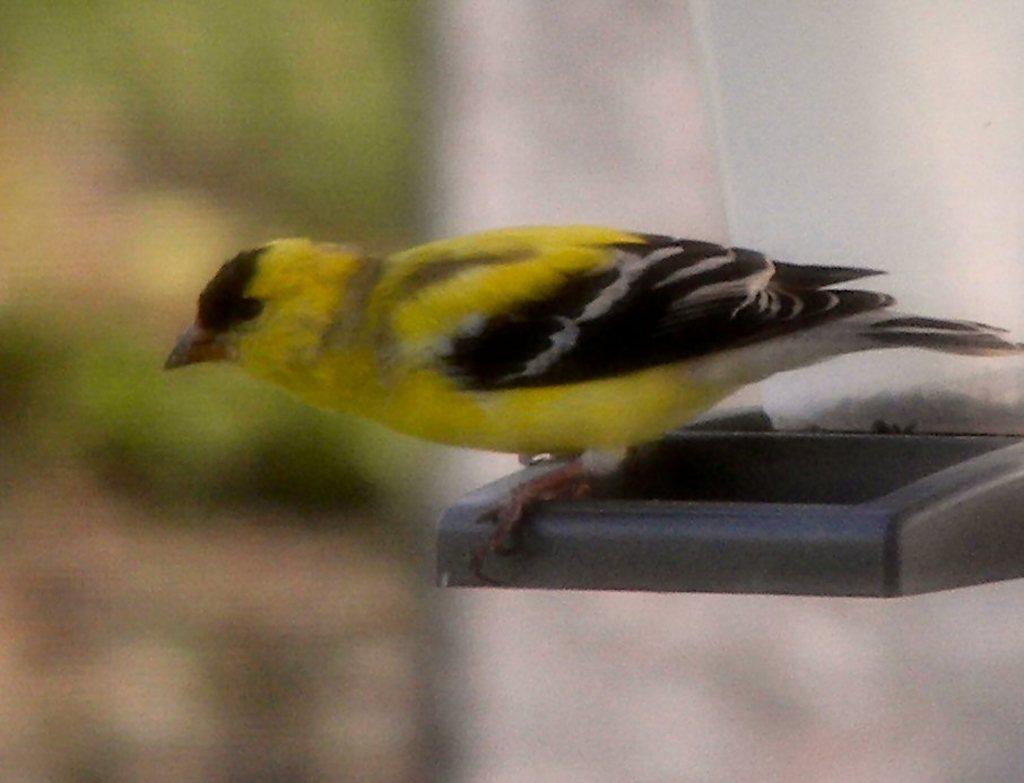Describe this image in one or two sentences. In the foreground of the picture we can see a bird on an object. The background is blurred. 